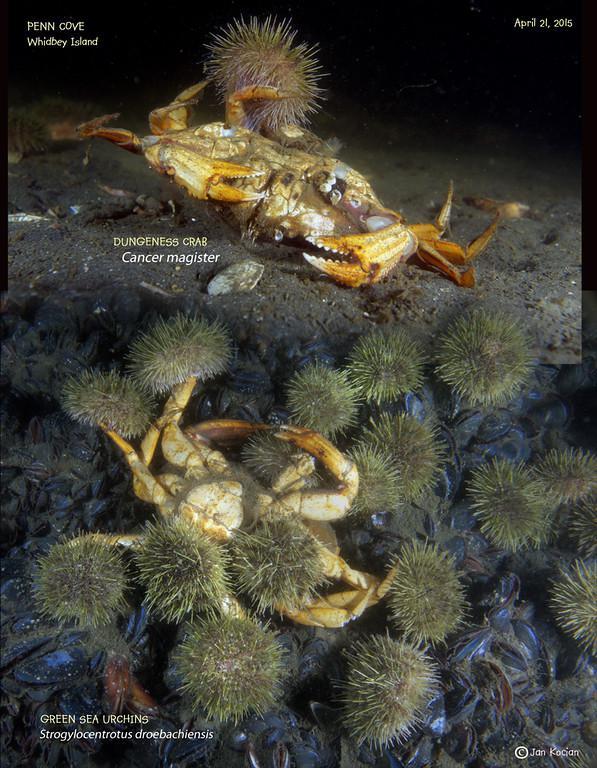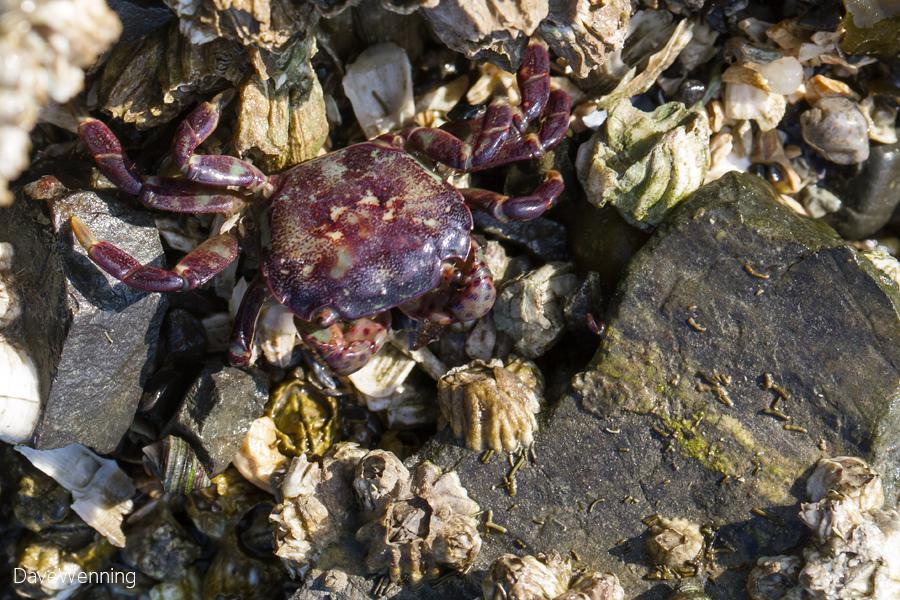The first image is the image on the left, the second image is the image on the right. Assess this claim about the two images: "In at least one image there is a single purple headed crab crawling in the ground.". Correct or not? Answer yes or no. Yes. 